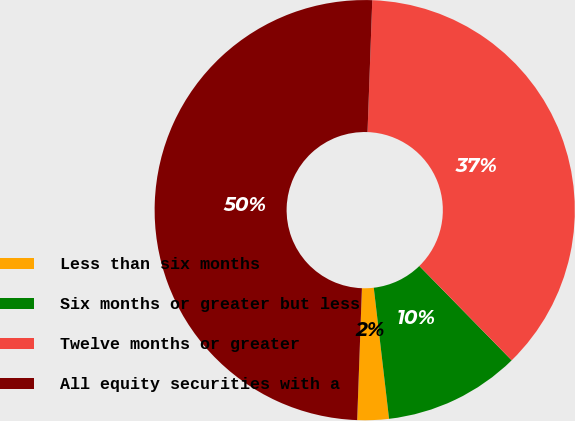Convert chart to OTSL. <chart><loc_0><loc_0><loc_500><loc_500><pie_chart><fcel>Less than six months<fcel>Six months or greater but less<fcel>Twelve months or greater<fcel>All equity securities with a<nl><fcel>2.42%<fcel>10.48%<fcel>37.1%<fcel>50.0%<nl></chart> 